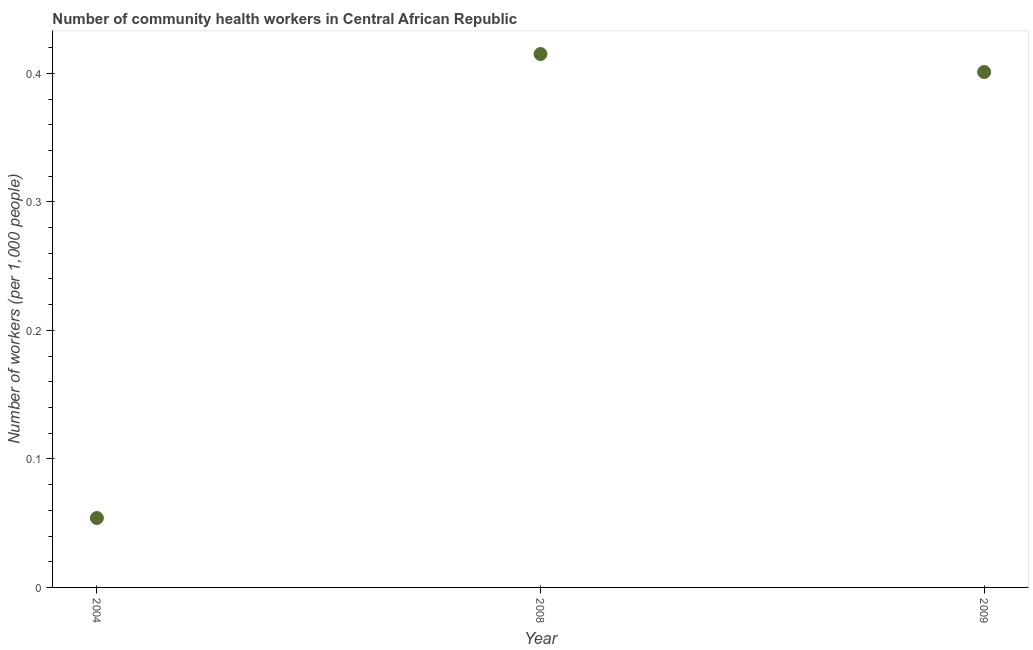What is the number of community health workers in 2009?
Offer a very short reply. 0.4. Across all years, what is the maximum number of community health workers?
Your answer should be very brief. 0.41. Across all years, what is the minimum number of community health workers?
Ensure brevity in your answer.  0.05. In which year was the number of community health workers maximum?
Provide a short and direct response. 2008. What is the sum of the number of community health workers?
Provide a short and direct response. 0.87. What is the difference between the number of community health workers in 2008 and 2009?
Your answer should be compact. 0.01. What is the average number of community health workers per year?
Give a very brief answer. 0.29. What is the median number of community health workers?
Offer a terse response. 0.4. Do a majority of the years between 2004 and 2008 (inclusive) have number of community health workers greater than 0.34 ?
Offer a very short reply. No. What is the ratio of the number of community health workers in 2004 to that in 2009?
Your answer should be very brief. 0.13. Is the difference between the number of community health workers in 2008 and 2009 greater than the difference between any two years?
Give a very brief answer. No. What is the difference between the highest and the second highest number of community health workers?
Provide a short and direct response. 0.01. What is the difference between the highest and the lowest number of community health workers?
Keep it short and to the point. 0.36. In how many years, is the number of community health workers greater than the average number of community health workers taken over all years?
Ensure brevity in your answer.  2. How many dotlines are there?
Provide a succinct answer. 1. What is the difference between two consecutive major ticks on the Y-axis?
Keep it short and to the point. 0.1. Does the graph contain any zero values?
Make the answer very short. No. What is the title of the graph?
Keep it short and to the point. Number of community health workers in Central African Republic. What is the label or title of the Y-axis?
Your answer should be compact. Number of workers (per 1,0 people). What is the Number of workers (per 1,000 people) in 2004?
Ensure brevity in your answer.  0.05. What is the Number of workers (per 1,000 people) in 2008?
Make the answer very short. 0.41. What is the Number of workers (per 1,000 people) in 2009?
Your response must be concise. 0.4. What is the difference between the Number of workers (per 1,000 people) in 2004 and 2008?
Offer a very short reply. -0.36. What is the difference between the Number of workers (per 1,000 people) in 2004 and 2009?
Keep it short and to the point. -0.35. What is the difference between the Number of workers (per 1,000 people) in 2008 and 2009?
Your answer should be compact. 0.01. What is the ratio of the Number of workers (per 1,000 people) in 2004 to that in 2008?
Keep it short and to the point. 0.13. What is the ratio of the Number of workers (per 1,000 people) in 2004 to that in 2009?
Make the answer very short. 0.14. What is the ratio of the Number of workers (per 1,000 people) in 2008 to that in 2009?
Your response must be concise. 1.03. 